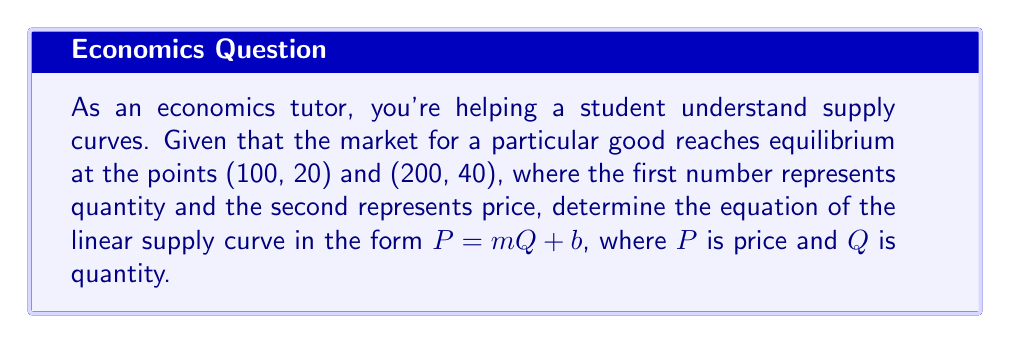Show me your answer to this math problem. To find the equation of the linear supply curve, we need to determine the slope (m) and y-intercept (b) using the given equilibrium points.

1. Calculate the slope (m):
   The slope represents the change in price divided by the change in quantity.
   
   $$m = \frac{P_2 - P_1}{Q_2 - Q_1} = \frac{40 - 20}{200 - 100} = \frac{20}{100} = 0.2$$

2. Use the point-slope form of a line:
   $P - P_1 = m(Q - Q_1)$
   
   Let's use the point (100, 20):
   $P - 20 = 0.2(Q - 100)$

3. Expand the equation:
   $P - 20 = 0.2Q - 20$

4. Solve for P to get the equation in the form $P = mQ + b$:
   $P = 0.2Q - 20 + 20$
   $P = 0.2Q + 0$

Therefore, the equation of the supply curve is $P = 0.2Q + 0$ or simply $P = 0.2Q$.

To verify, we can check if both given points satisfy this equation:
- For (100, 20): $20 = 0.2(100) + 0 = 20$ ✓
- For (200, 40): $40 = 0.2(200) + 0 = 40$ ✓
Answer: $P = 0.2Q$ 